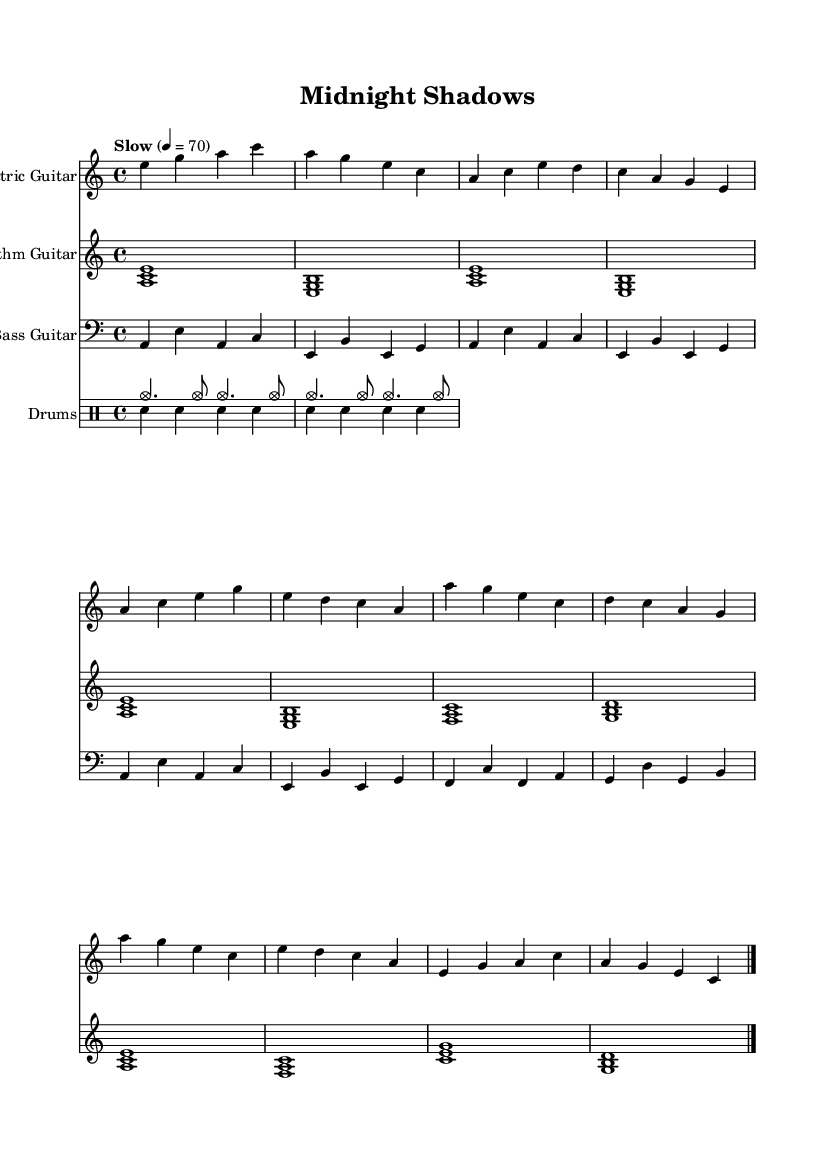What is the key signature of this music? The key signature is A minor, which has no sharps or flats.
Answer: A minor What is the time signature of this music? The time signature is indicated at the beginning of the sheet music, showing that each measure contains four beats.
Answer: 4/4 What is the tempo marking of this piece? The tempo marking is specified as "Slow" with a metronome indication of 70 beats per minute, indicating a relatively slow pace.
Answer: Slow, 70 How many measures are in the intro section? Counting the measures in the electric guitar part, the intro consists of two measures of music.
Answer: 2 Which instrument plays the walking bass line? The bass guitar part distinctly features a walking bass line, as shown by the rhythmic variation and note choices in the bass staff.
Answer: Bass Guitar What is the overall mood conveyed by the piece? The music's structure, instrumentation, and minor key create a moody and melancholic atmosphere typical of blues and noir film soundtracks, using the electric guitar's expressive capabilities.
Answer: Moody How many different instruments are used in this score? The score consists of four distinct instruments: electric guitar, rhythm guitar, bass guitar, and drums, created for a full band experience.
Answer: 4 